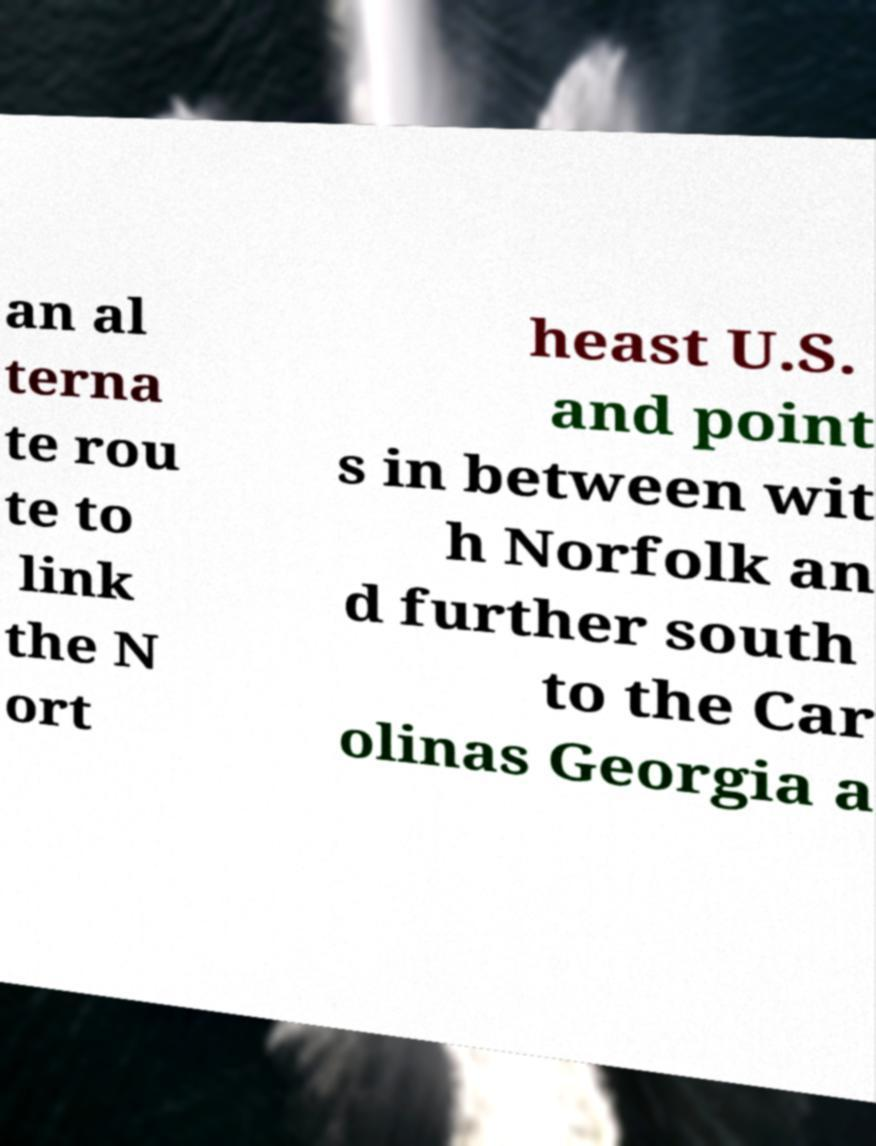Can you read and provide the text displayed in the image?This photo seems to have some interesting text. Can you extract and type it out for me? an al terna te rou te to link the N ort heast U.S. and point s in between wit h Norfolk an d further south to the Car olinas Georgia a 